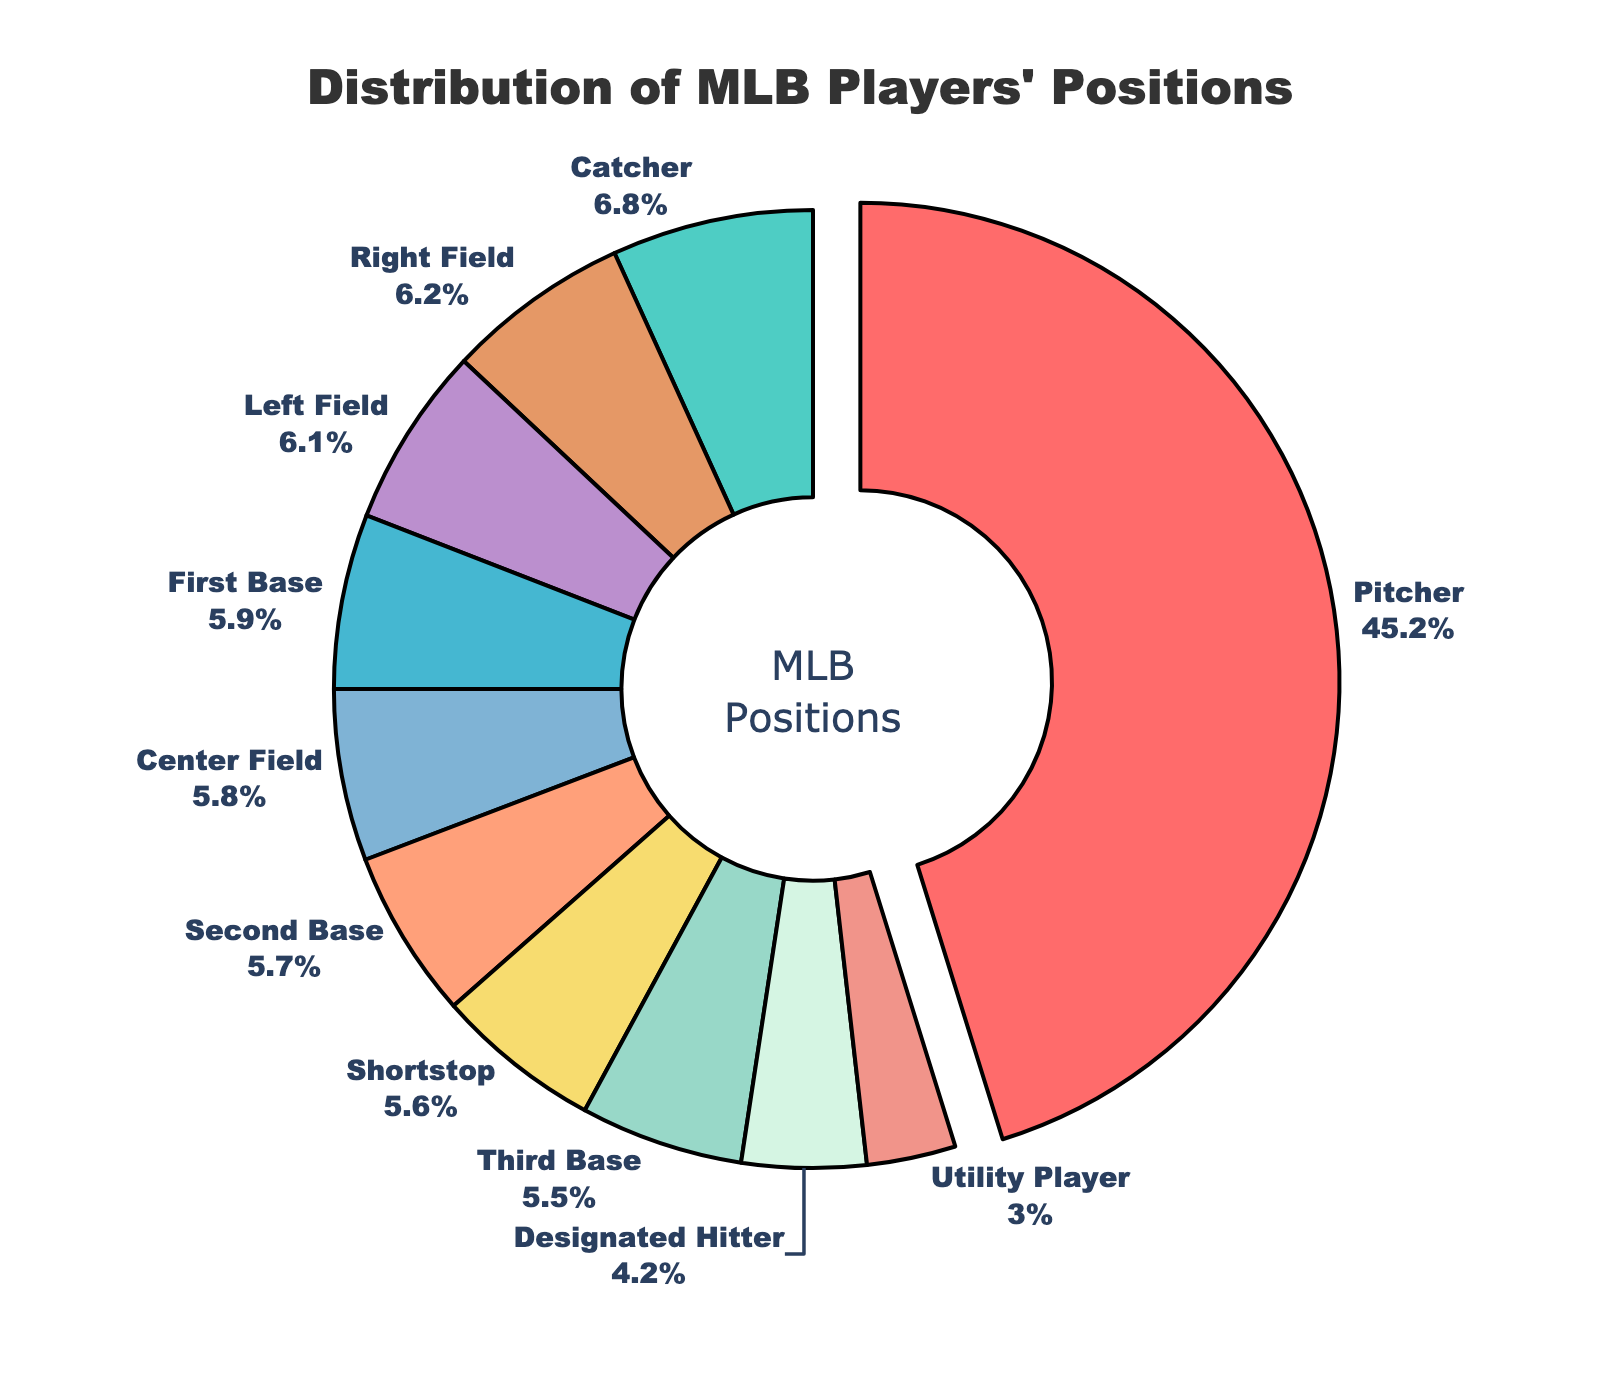What percentage of players were pitchers? The slice labeled "Pitcher" shows the percentage value directly, which is 45.2%.
Answer: 45.2% What position had the smallest percentage, and what was it? The Utility Player position has the smallest percentage, which can be seen as the smallest slice in the pie chart, and it is 3.0%.
Answer: Utility Player, 3.0% How does the percentage of right fielders compare to that of center fielders? The percentage of right fielders is 6.2%, and the percentage of center fielders is 5.8%. Comparing these values, right fielders have a slightly higher percentage.
Answer: Right fielders have a higher percentage Which three positions combined account for the highest percentage, and what is their total? Adding the percentages of the three highest positions: Pitcher (45.2%), Right Field (6.2%), and Left Field (6.1%), we get 45.2% + 6.2% + 6.1% = 57.5%.
Answer: Pitcher, Right Field, and Left Field; 57.5% Is there a position that accounts for more than 40% of players? From the chart, it is clear that the Pitcher position accounts for more than 40%, specifically 45.2%.
Answer: Yes, Pitcher What is the combined percentage of infield positions (First Base, Second Base, Third Base, Shortstop)? Adding the percentages of First Base (5.9%), Second Base (5.7%), Third Base (5.5%), and Shortstop (5.6%), the total is 5.9% + 5.7% + 5.5% + 5.6% = 22.7%.
Answer: 22.7% If we group outfield positions (Left Field, Center Field, Right Field) together, what is their total percentage? Adding the percentages of Left Field (6.1%), Center Field (5.8%), and Right Field (6.2%), the total is 6.1% + 5.8% + 6.2% = 18.1%.
Answer: 18.1% Which position is represented by a slice that stands out visually due to its size? The Pitcher slice stands out visually due to its size, being the largest in the pie chart.
Answer: Pitcher What visual feature highlights the position with the highest percentage? The slice representing the highest percentage (Pitcher) is pulled out slightly from the pie chart.
Answer: The slice is pulled out How do the percentages of Catchers compare to Designated Hitters? The percentage of Catchers is 6.8%, while the percentage of Designated Hitters is 4.2%. Comparison shows that Catchers have a higher percentage.
Answer: Catchers have a higher percentage 